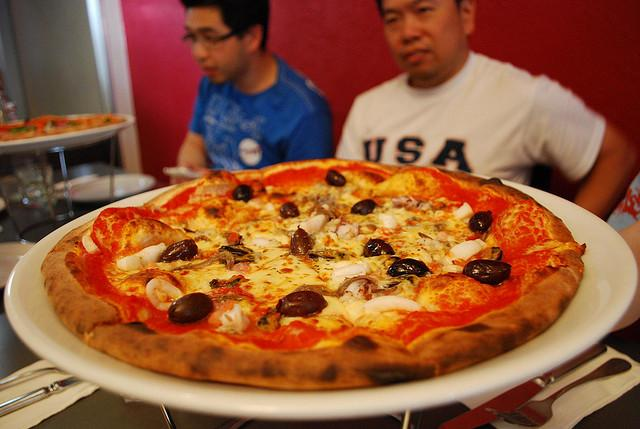What country does the shirt on the right mention? Please explain your reasoning. usa. The white shirt has three letters that represent a country in north america. 